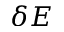Convert formula to latex. <formula><loc_0><loc_0><loc_500><loc_500>\delta E</formula> 